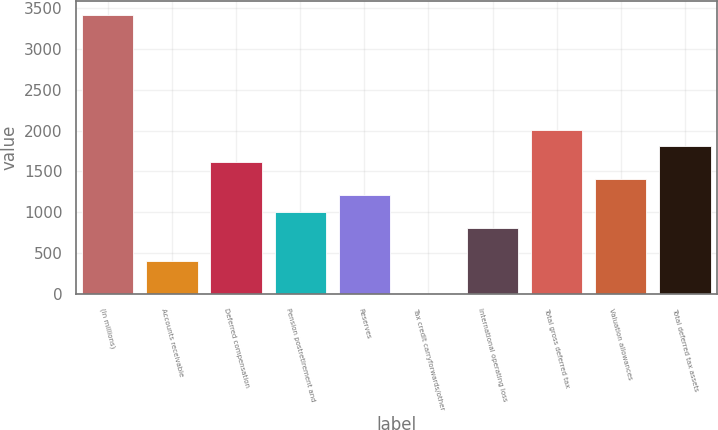Convert chart to OTSL. <chart><loc_0><loc_0><loc_500><loc_500><bar_chart><fcel>(In millions)<fcel>Accounts receivable<fcel>Deferred compensation<fcel>Pension postretirement and<fcel>Reserves<fcel>Tax credit carryforwards/other<fcel>International operating loss<fcel>Total gross deferred tax<fcel>Valuation allowances<fcel>Total deferred tax assets<nl><fcel>3418.49<fcel>402.44<fcel>1608.86<fcel>1005.65<fcel>1206.72<fcel>0.3<fcel>804.58<fcel>2011<fcel>1407.79<fcel>1809.93<nl></chart> 